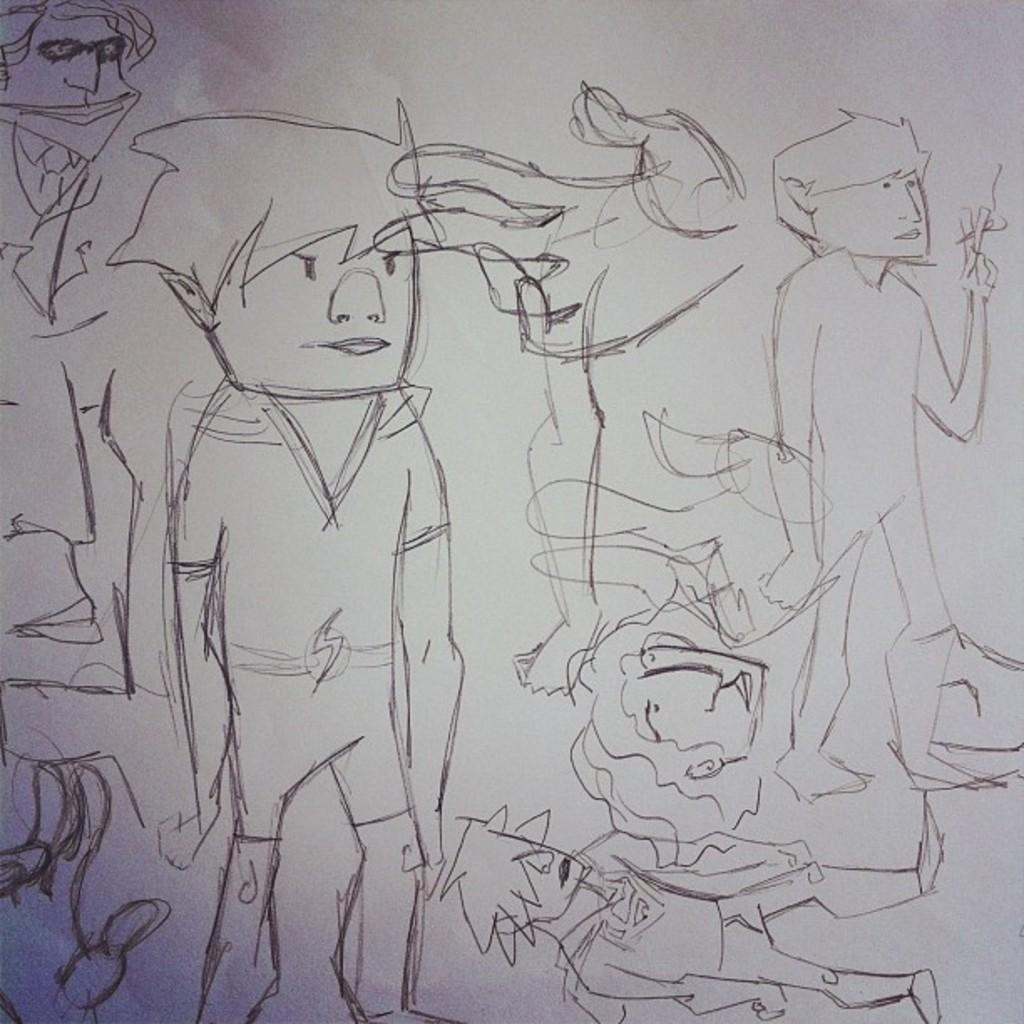What is depicted on the paper in the image? There are drawings on the paper in the image. What type of park can be seen in the image? There is no park present in the image; it only shows drawings on a paper. What is the source of power for the drawings in the image? The drawings on the paper are not powered by any source; they are static images. 